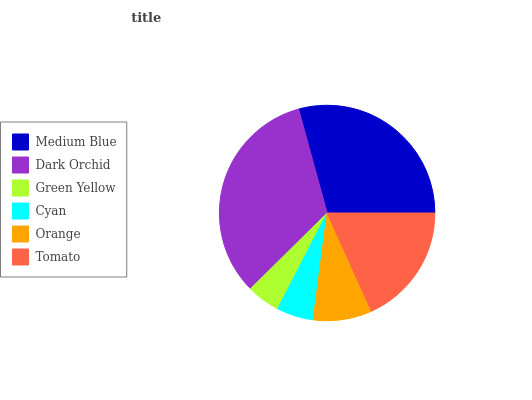Is Green Yellow the minimum?
Answer yes or no. Yes. Is Dark Orchid the maximum?
Answer yes or no. Yes. Is Dark Orchid the minimum?
Answer yes or no. No. Is Green Yellow the maximum?
Answer yes or no. No. Is Dark Orchid greater than Green Yellow?
Answer yes or no. Yes. Is Green Yellow less than Dark Orchid?
Answer yes or no. Yes. Is Green Yellow greater than Dark Orchid?
Answer yes or no. No. Is Dark Orchid less than Green Yellow?
Answer yes or no. No. Is Tomato the high median?
Answer yes or no. Yes. Is Orange the low median?
Answer yes or no. Yes. Is Orange the high median?
Answer yes or no. No. Is Tomato the low median?
Answer yes or no. No. 